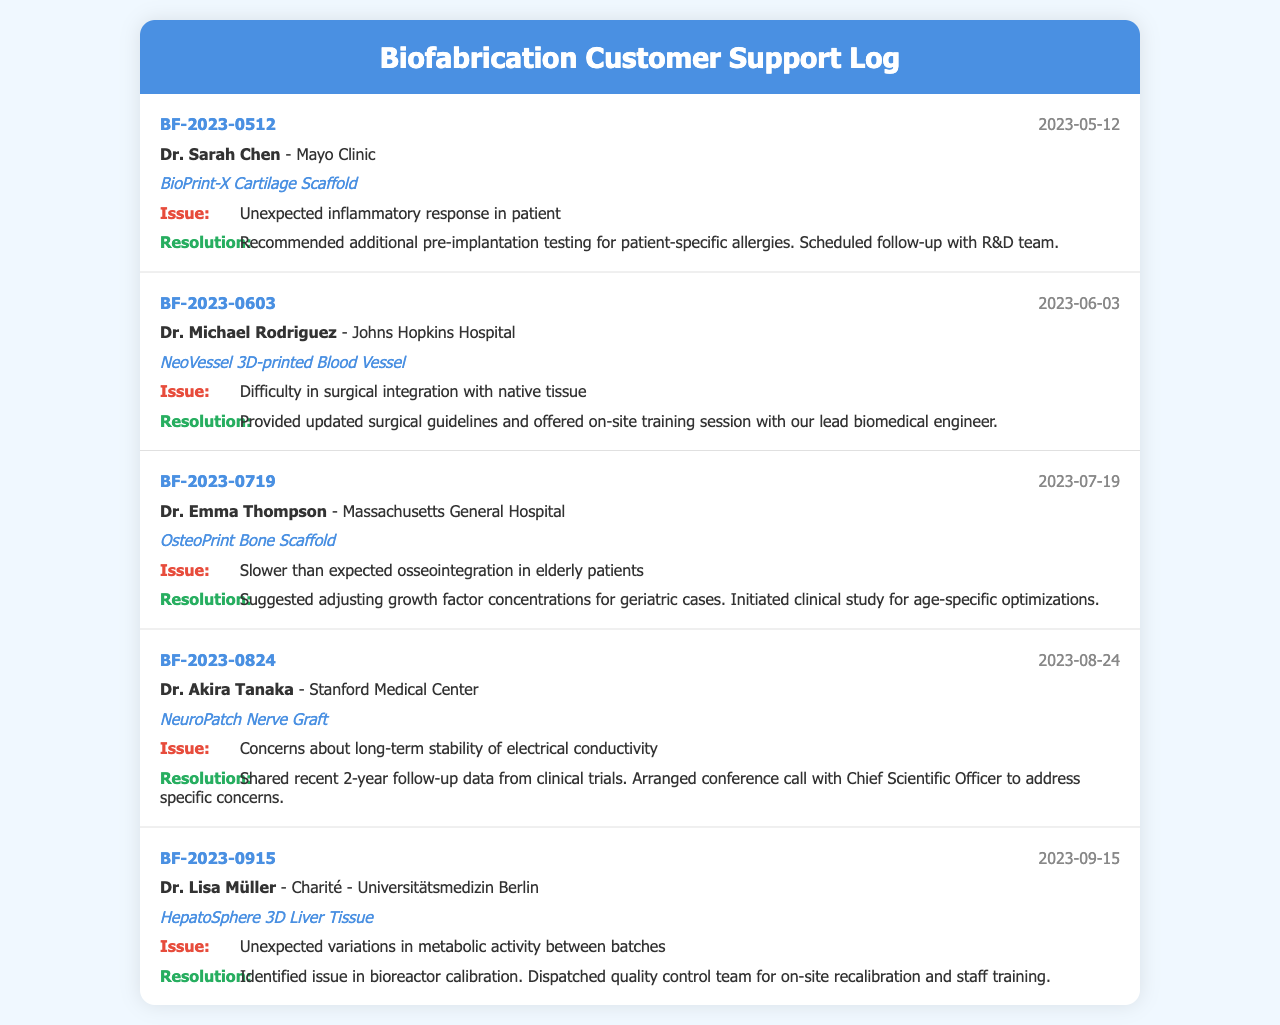What is the call ID for the first log entry? The call ID is a unique identifier listed for each call; the first entry has the call ID BF-2023-0512.
Answer: BF-2023-0512 Who is the customer for the second log entry? The customer's name is mentioned in the customer info section; for the second entry, it is Dr. Michael Rodriguez.
Answer: Dr. Michael Rodriguez What is the product mentioned in the third log entry? The product is the focus of the entry, specifically listed as OsteoPrint Bone Scaffold in the third log.
Answer: OsteoPrint Bone Scaffold What issue was reported by Dr. Lisa Müller? The issue section outlines problems faced by the customer; Dr. Lisa Müller reported unexpected variations in metabolic activity between batches.
Answer: Unexpected variations in metabolic activity between batches How was the issue of the unexpected inflammatory response addressed? The resolution section describes how the issue was handled, stating to recommend additional pre-implantation testing for patient-specific allergies.
Answer: Recommended additional pre-implantation testing for patient-specific allergies Which date did Dr. Akira Tanaka make the support call? The date is situated alongside each log entry; for Dr. Akira Tanaka’s entry, the call was made on 2023-08-24.
Answer: 2023-08-24 What follow-up was scheduled after Dr. Sarah Chen's issue? The resolution talks about the follow-up action taken; a follow-up was scheduled with the R&D team.
Answer: Scheduled follow-up with R&D team What concern did Dr. Akira Tanaka have regarding the product? The concern highlighted under the issue in the log is about the long-term stability of electrical conductivity.
Answer: Long-term stability of electrical conductivity 